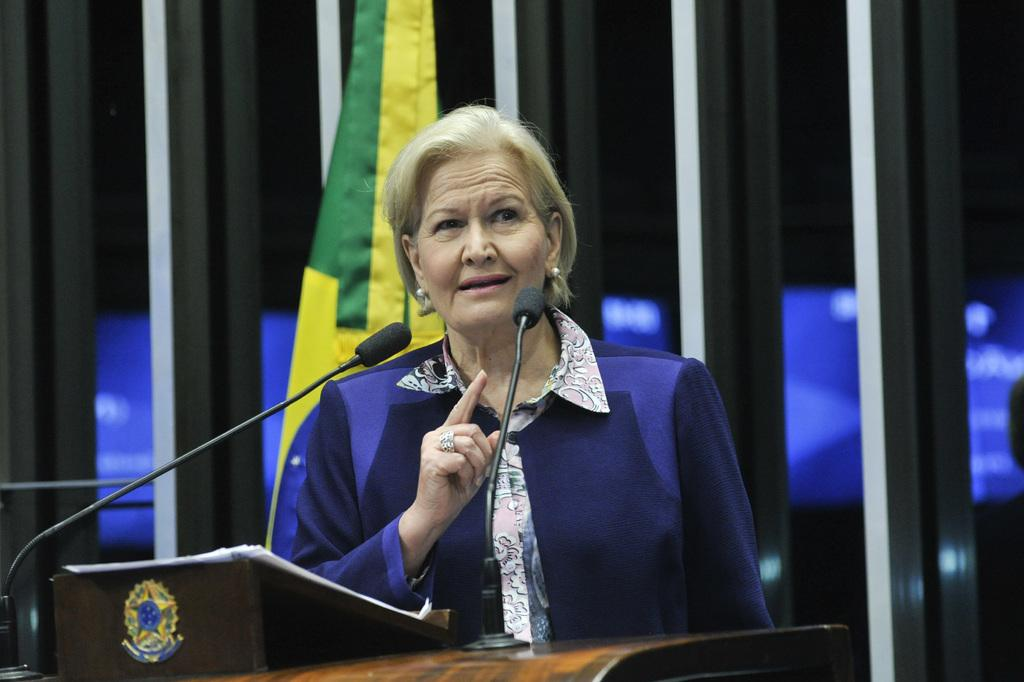Who is the main subject in the image? There is a lady in the image. What is the lady doing in the image? The lady is standing behind a podium and talking. What is the lady wearing in the image? The lady is wearing a blue coat. What items can be seen on the podium? There are papers and mics on the podium. What is visible in the background of the image? There is a wall and a flag in the background of the image. What type of flower is the lady holding in the image? There is no flower present in the image; the lady is standing behind a podium and talking. How many sisters does the lady have in the image? There is no information about the lady's sisters in the image. 